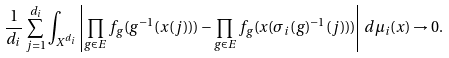<formula> <loc_0><loc_0><loc_500><loc_500>\frac { 1 } { d _ { i } } \sum _ { j = 1 } ^ { d _ { i } } \int _ { X ^ { d _ { i } } } \left | \prod _ { g \in E } f _ { g } ( g ^ { - 1 } ( x ( j ) ) ) - \prod _ { g \in E } f _ { g } ( x ( \sigma _ { i } ( g ) ^ { - 1 } ( j ) ) ) \right | \, d \mu _ { i } ( x ) \to 0 .</formula> 